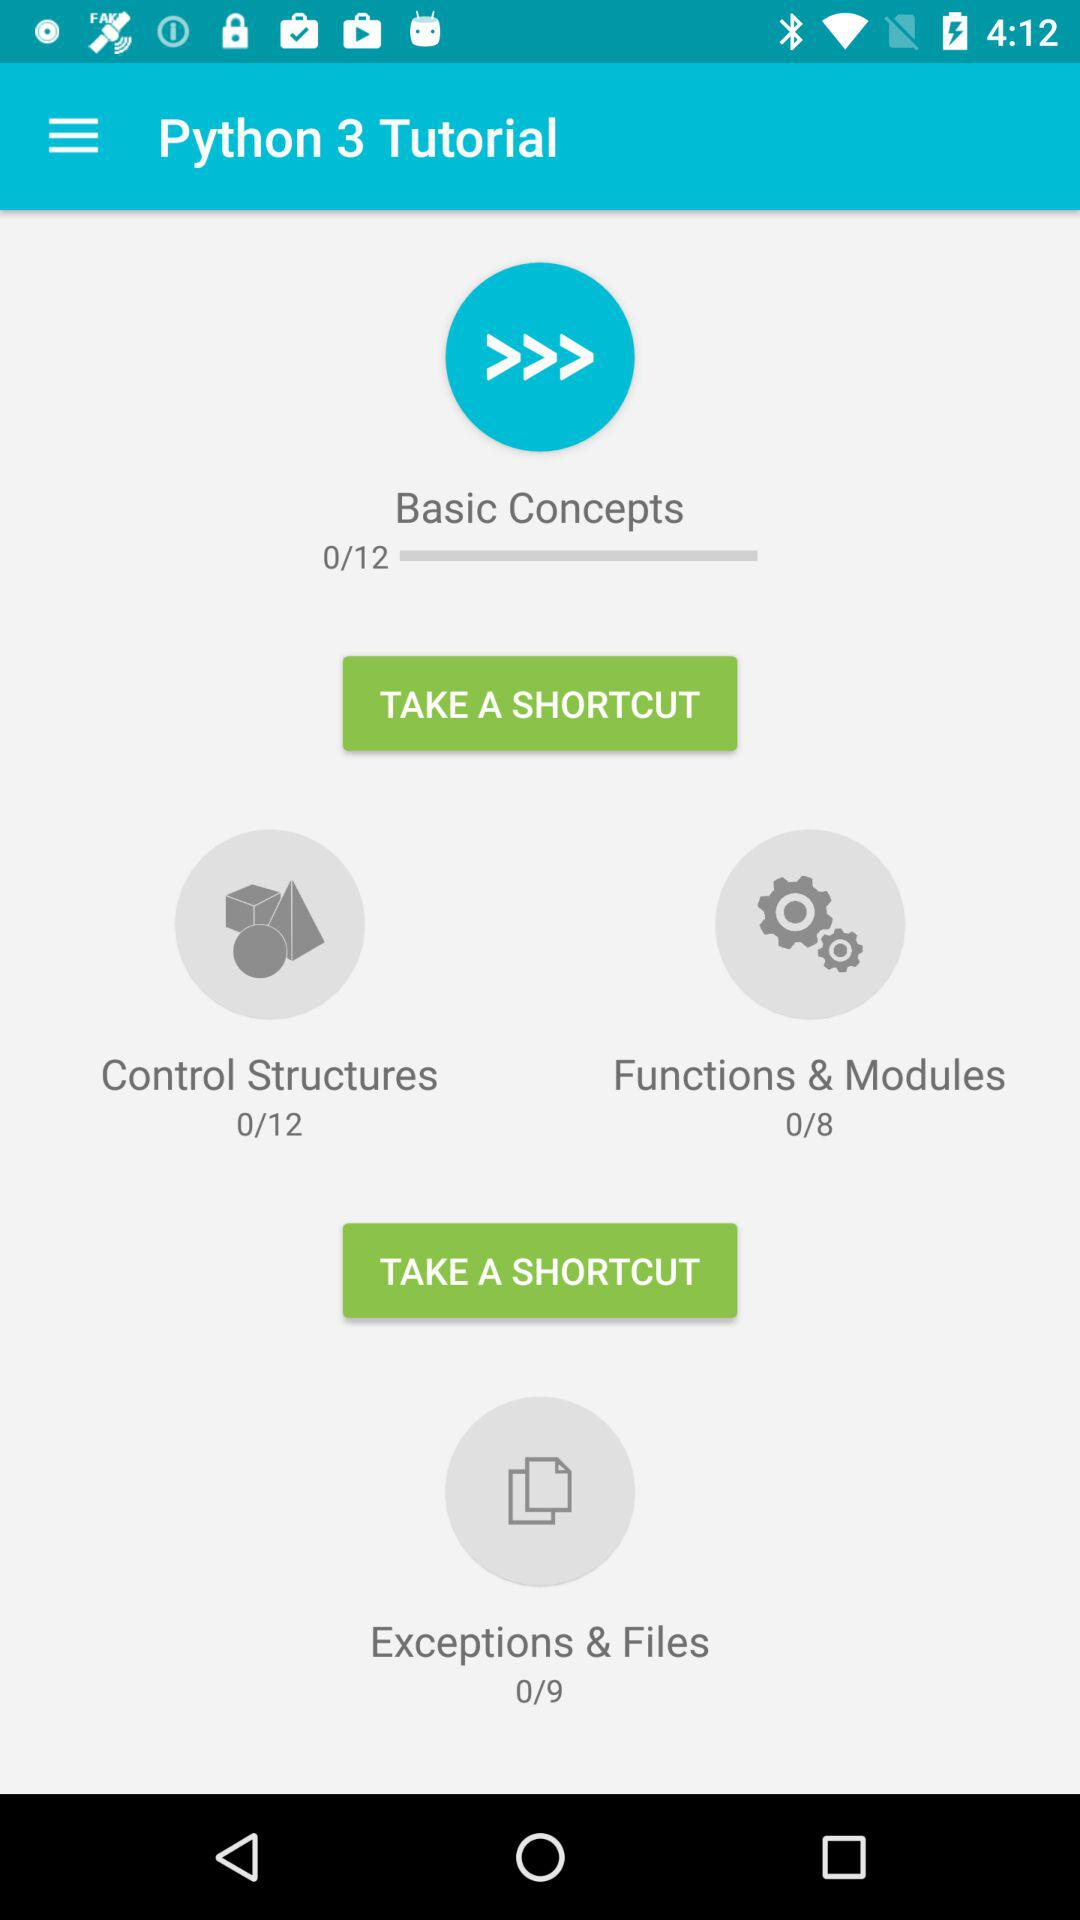How many lessons are there in the Functions & Modules section?
Answer the question using a single word or phrase. 8 